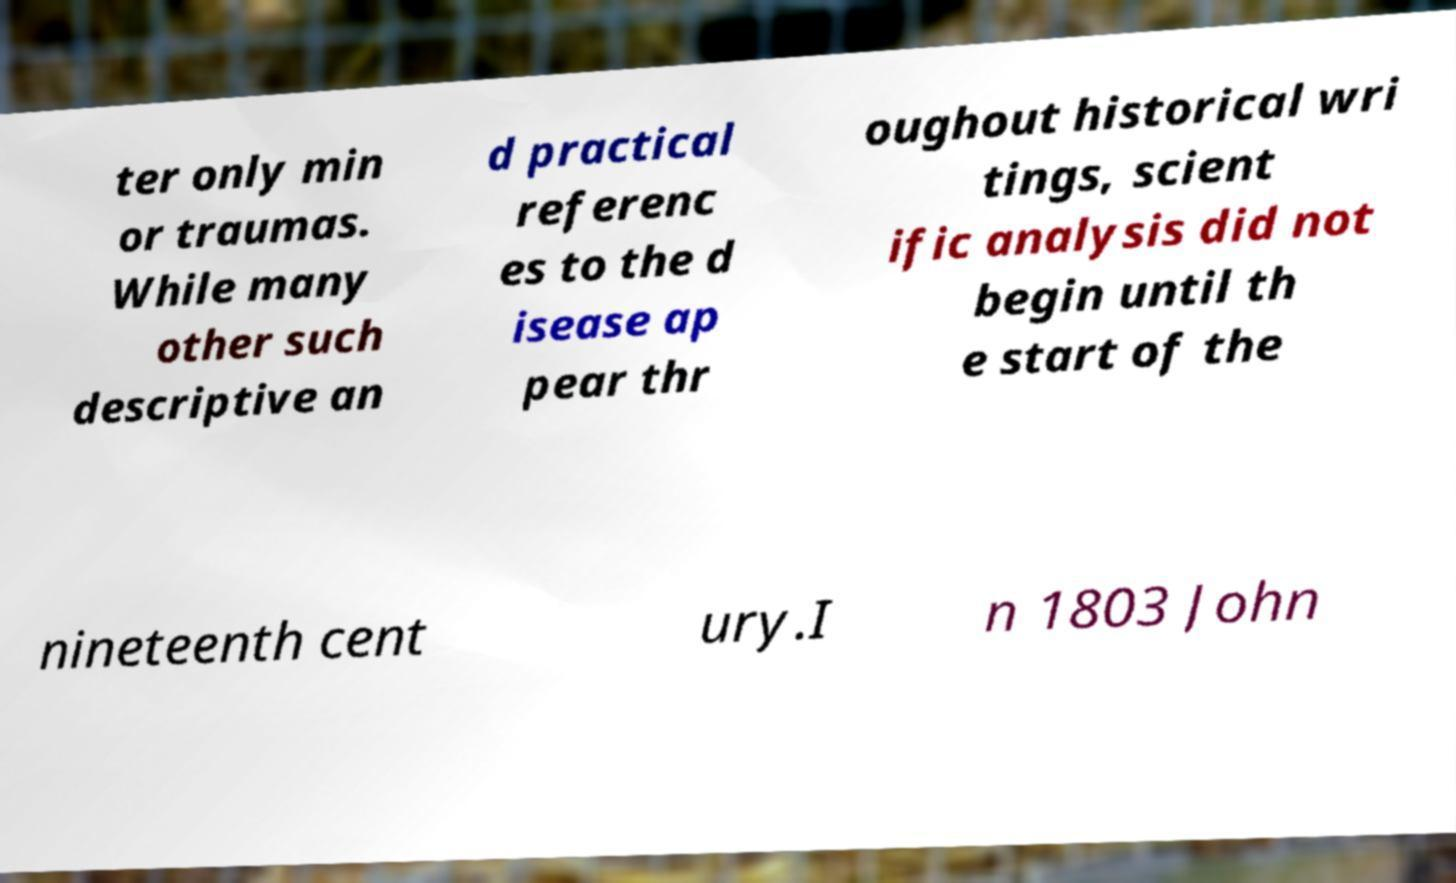Could you assist in decoding the text presented in this image and type it out clearly? ter only min or traumas. While many other such descriptive an d practical referenc es to the d isease ap pear thr oughout historical wri tings, scient ific analysis did not begin until th e start of the nineteenth cent ury.I n 1803 John 